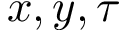<formula> <loc_0><loc_0><loc_500><loc_500>x , y , \tau</formula> 